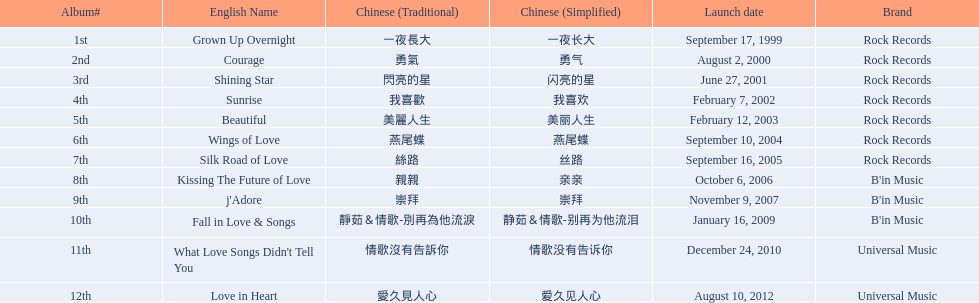Was the album beautiful released before the album love in heart? Yes. 